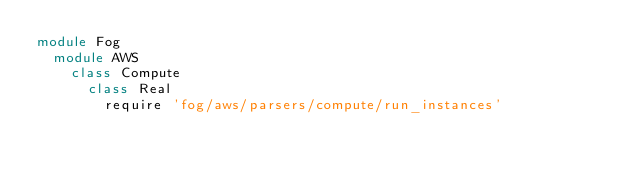<code> <loc_0><loc_0><loc_500><loc_500><_Ruby_>module Fog
  module AWS
    class Compute
      class Real
        require 'fog/aws/parsers/compute/run_instances'
</code> 